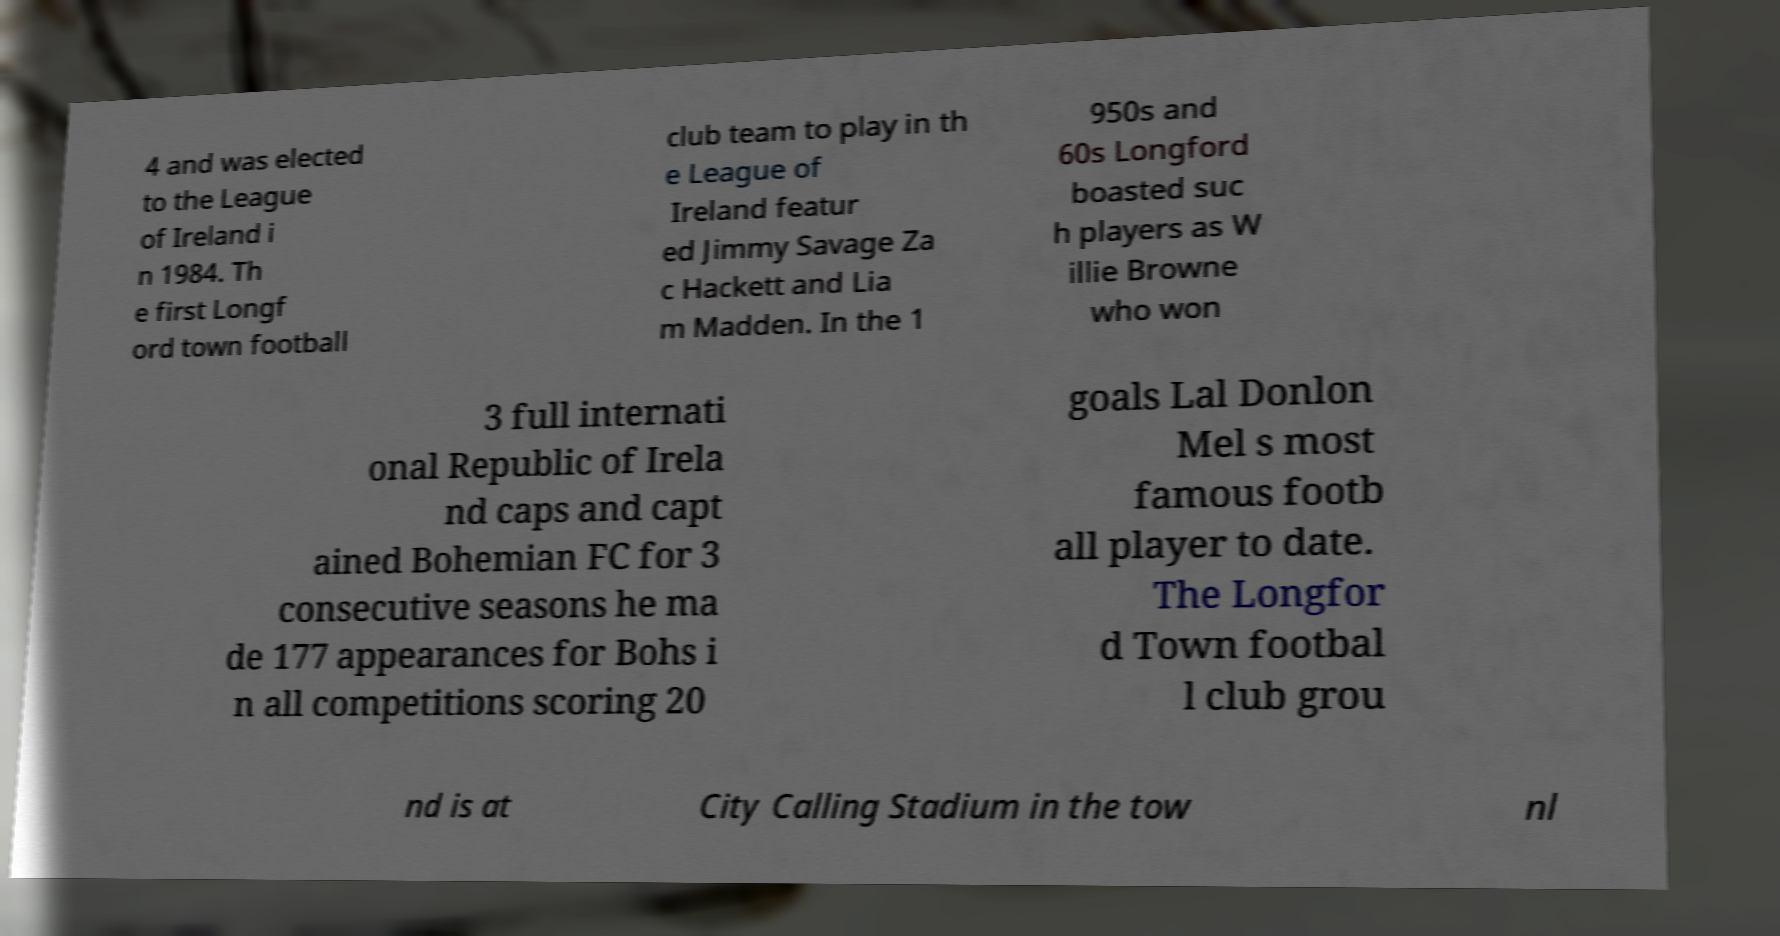What messages or text are displayed in this image? I need them in a readable, typed format. 4 and was elected to the League of Ireland i n 1984. Th e first Longf ord town football club team to play in th e League of Ireland featur ed Jimmy Savage Za c Hackett and Lia m Madden. In the 1 950s and 60s Longford boasted suc h players as W illie Browne who won 3 full internati onal Republic of Irela nd caps and capt ained Bohemian FC for 3 consecutive seasons he ma de 177 appearances for Bohs i n all competitions scoring 20 goals Lal Donlon Mel s most famous footb all player to date. The Longfor d Town footbal l club grou nd is at City Calling Stadium in the tow nl 